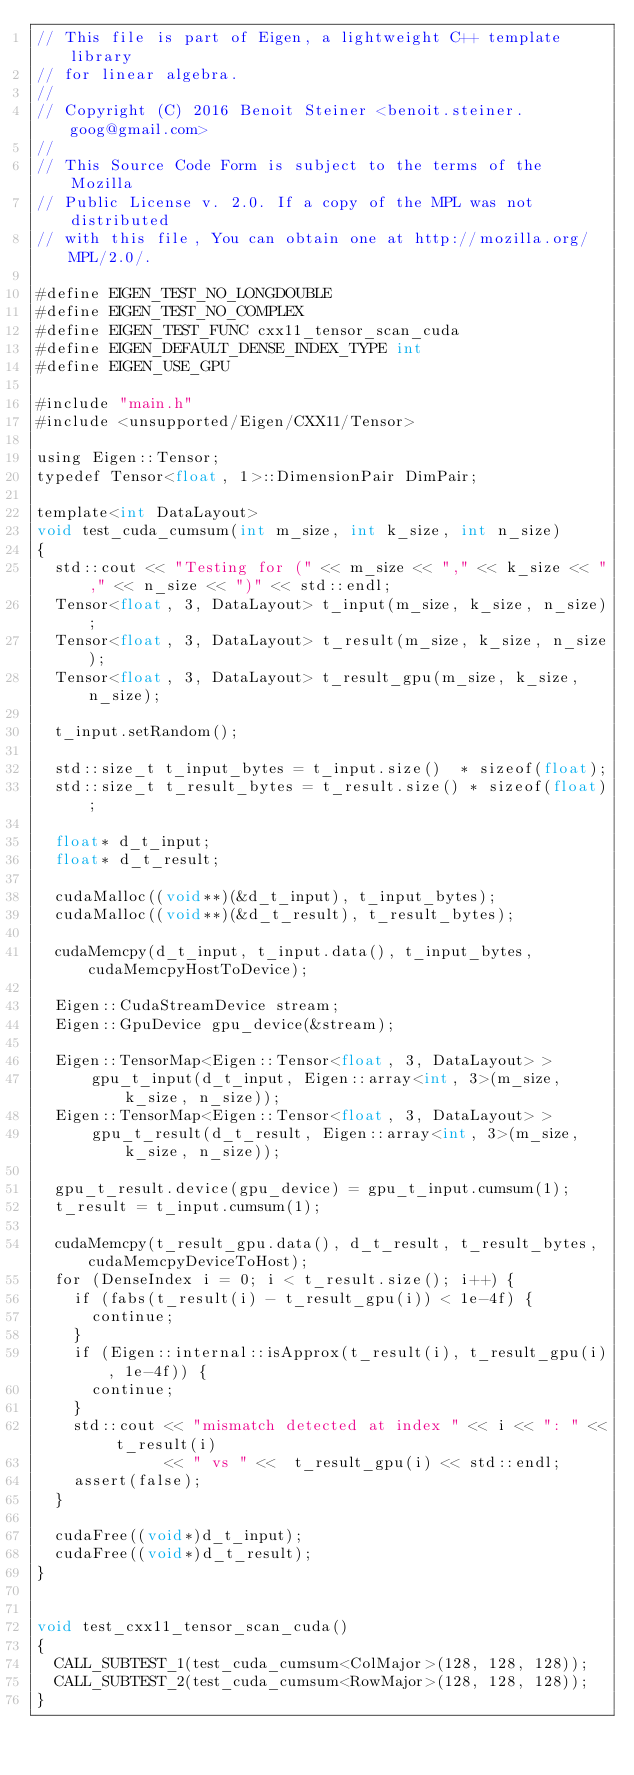<code> <loc_0><loc_0><loc_500><loc_500><_Cuda_>// This file is part of Eigen, a lightweight C++ template library
// for linear algebra.
//
// Copyright (C) 2016 Benoit Steiner <benoit.steiner.goog@gmail.com>
//
// This Source Code Form is subject to the terms of the Mozilla
// Public License v. 2.0. If a copy of the MPL was not distributed
// with this file, You can obtain one at http://mozilla.org/MPL/2.0/.

#define EIGEN_TEST_NO_LONGDOUBLE
#define EIGEN_TEST_NO_COMPLEX
#define EIGEN_TEST_FUNC cxx11_tensor_scan_cuda
#define EIGEN_DEFAULT_DENSE_INDEX_TYPE int
#define EIGEN_USE_GPU

#include "main.h"
#include <unsupported/Eigen/CXX11/Tensor>

using Eigen::Tensor;
typedef Tensor<float, 1>::DimensionPair DimPair;

template<int DataLayout>
void test_cuda_cumsum(int m_size, int k_size, int n_size)
{
  std::cout << "Testing for (" << m_size << "," << k_size << "," << n_size << ")" << std::endl;
  Tensor<float, 3, DataLayout> t_input(m_size, k_size, n_size);
  Tensor<float, 3, DataLayout> t_result(m_size, k_size, n_size);
  Tensor<float, 3, DataLayout> t_result_gpu(m_size, k_size, n_size);

  t_input.setRandom();

  std::size_t t_input_bytes = t_input.size()  * sizeof(float);
  std::size_t t_result_bytes = t_result.size() * sizeof(float);

  float* d_t_input;
  float* d_t_result;

  cudaMalloc((void**)(&d_t_input), t_input_bytes);
  cudaMalloc((void**)(&d_t_result), t_result_bytes);

  cudaMemcpy(d_t_input, t_input.data(), t_input_bytes, cudaMemcpyHostToDevice);

  Eigen::CudaStreamDevice stream;
  Eigen::GpuDevice gpu_device(&stream);

  Eigen::TensorMap<Eigen::Tensor<float, 3, DataLayout> >
      gpu_t_input(d_t_input, Eigen::array<int, 3>(m_size, k_size, n_size));
  Eigen::TensorMap<Eigen::Tensor<float, 3, DataLayout> >
      gpu_t_result(d_t_result, Eigen::array<int, 3>(m_size, k_size, n_size));

  gpu_t_result.device(gpu_device) = gpu_t_input.cumsum(1);
  t_result = t_input.cumsum(1);

  cudaMemcpy(t_result_gpu.data(), d_t_result, t_result_bytes, cudaMemcpyDeviceToHost);
  for (DenseIndex i = 0; i < t_result.size(); i++) {
    if (fabs(t_result(i) - t_result_gpu(i)) < 1e-4f) {
      continue;
    }
    if (Eigen::internal::isApprox(t_result(i), t_result_gpu(i), 1e-4f)) {
      continue;
    }
    std::cout << "mismatch detected at index " << i << ": " << t_result(i)
              << " vs " <<  t_result_gpu(i) << std::endl;
    assert(false);
  }

  cudaFree((void*)d_t_input);
  cudaFree((void*)d_t_result);
}


void test_cxx11_tensor_scan_cuda()
{
  CALL_SUBTEST_1(test_cuda_cumsum<ColMajor>(128, 128, 128));
  CALL_SUBTEST_2(test_cuda_cumsum<RowMajor>(128, 128, 128));
}
</code> 